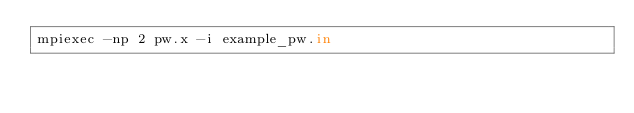Convert code to text. <code><loc_0><loc_0><loc_500><loc_500><_Bash_>mpiexec -np 2 pw.x -i example_pw.in
</code> 